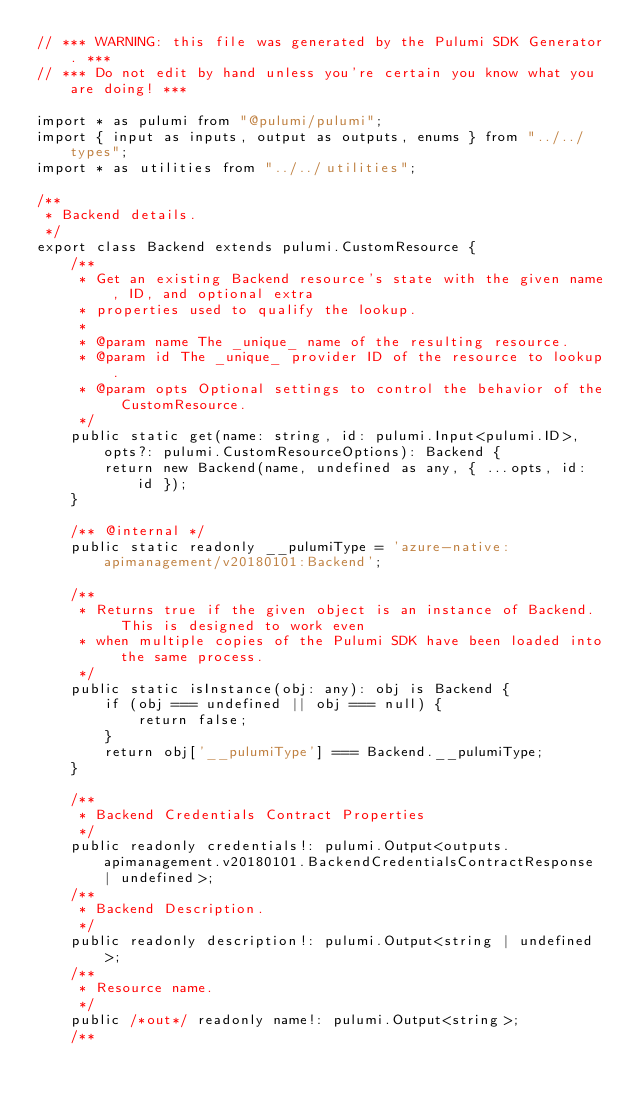<code> <loc_0><loc_0><loc_500><loc_500><_TypeScript_>// *** WARNING: this file was generated by the Pulumi SDK Generator. ***
// *** Do not edit by hand unless you're certain you know what you are doing! ***

import * as pulumi from "@pulumi/pulumi";
import { input as inputs, output as outputs, enums } from "../../types";
import * as utilities from "../../utilities";

/**
 * Backend details.
 */
export class Backend extends pulumi.CustomResource {
    /**
     * Get an existing Backend resource's state with the given name, ID, and optional extra
     * properties used to qualify the lookup.
     *
     * @param name The _unique_ name of the resulting resource.
     * @param id The _unique_ provider ID of the resource to lookup.
     * @param opts Optional settings to control the behavior of the CustomResource.
     */
    public static get(name: string, id: pulumi.Input<pulumi.ID>, opts?: pulumi.CustomResourceOptions): Backend {
        return new Backend(name, undefined as any, { ...opts, id: id });
    }

    /** @internal */
    public static readonly __pulumiType = 'azure-native:apimanagement/v20180101:Backend';

    /**
     * Returns true if the given object is an instance of Backend.  This is designed to work even
     * when multiple copies of the Pulumi SDK have been loaded into the same process.
     */
    public static isInstance(obj: any): obj is Backend {
        if (obj === undefined || obj === null) {
            return false;
        }
        return obj['__pulumiType'] === Backend.__pulumiType;
    }

    /**
     * Backend Credentials Contract Properties
     */
    public readonly credentials!: pulumi.Output<outputs.apimanagement.v20180101.BackendCredentialsContractResponse | undefined>;
    /**
     * Backend Description.
     */
    public readonly description!: pulumi.Output<string | undefined>;
    /**
     * Resource name.
     */
    public /*out*/ readonly name!: pulumi.Output<string>;
    /**</code> 